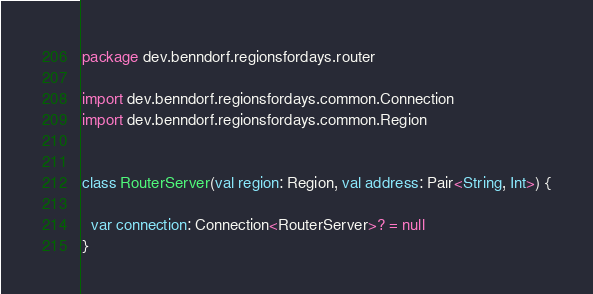Convert code to text. <code><loc_0><loc_0><loc_500><loc_500><_Kotlin_>package dev.benndorf.regionsfordays.router

import dev.benndorf.regionsfordays.common.Connection
import dev.benndorf.regionsfordays.common.Region


class RouterServer(val region: Region, val address: Pair<String, Int>) {

  var connection: Connection<RouterServer>? = null
}
</code> 